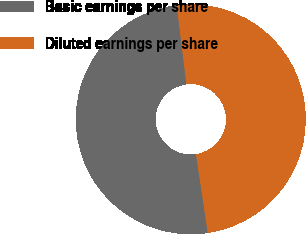Convert chart. <chart><loc_0><loc_0><loc_500><loc_500><pie_chart><fcel>Basic earnings per share<fcel>Diluted earnings per share<nl><fcel>50.42%<fcel>49.58%<nl></chart> 